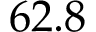Convert formula to latex. <formula><loc_0><loc_0><loc_500><loc_500>6 2 . 8</formula> 